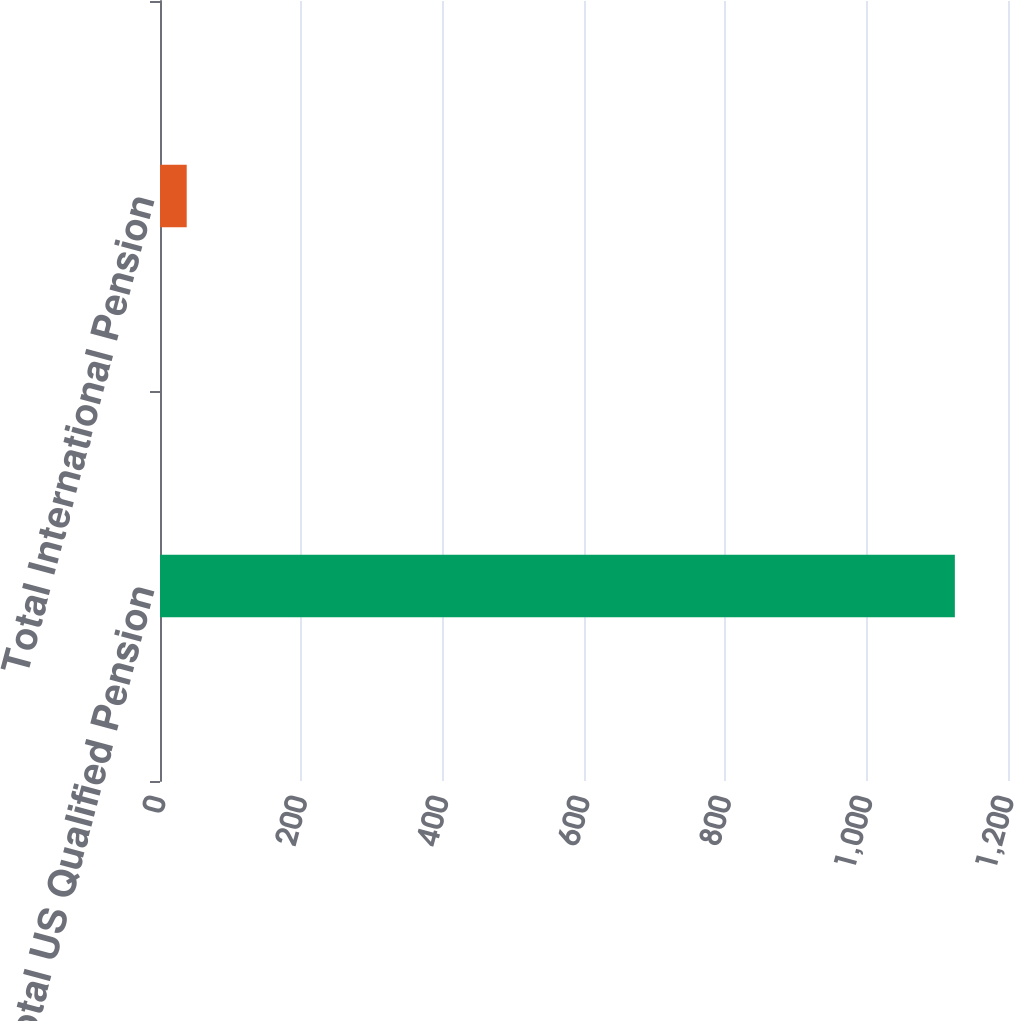<chart> <loc_0><loc_0><loc_500><loc_500><bar_chart><fcel>Total US Qualified Pension<fcel>Total International Pension<nl><fcel>1124.8<fcel>37.8<nl></chart> 